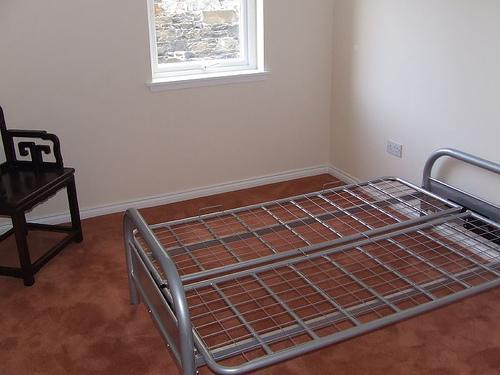How many beds are in the picture?
Give a very brief answer. 0. How many cats with green eyes are there?
Give a very brief answer. 0. 